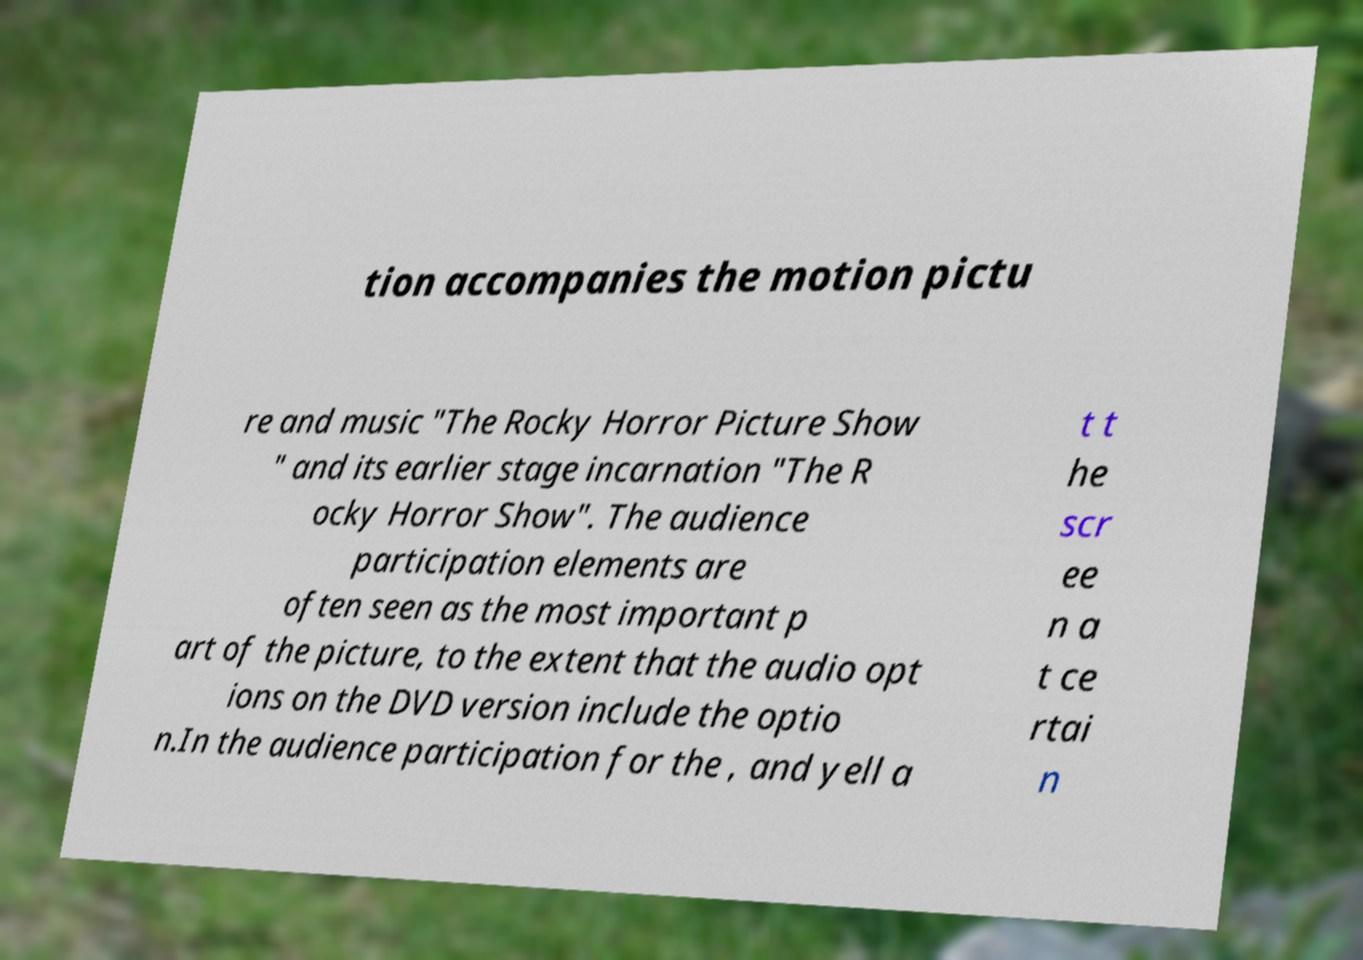Could you assist in decoding the text presented in this image and type it out clearly? tion accompanies the motion pictu re and music "The Rocky Horror Picture Show " and its earlier stage incarnation "The R ocky Horror Show". The audience participation elements are often seen as the most important p art of the picture, to the extent that the audio opt ions on the DVD version include the optio n.In the audience participation for the , and yell a t t he scr ee n a t ce rtai n 